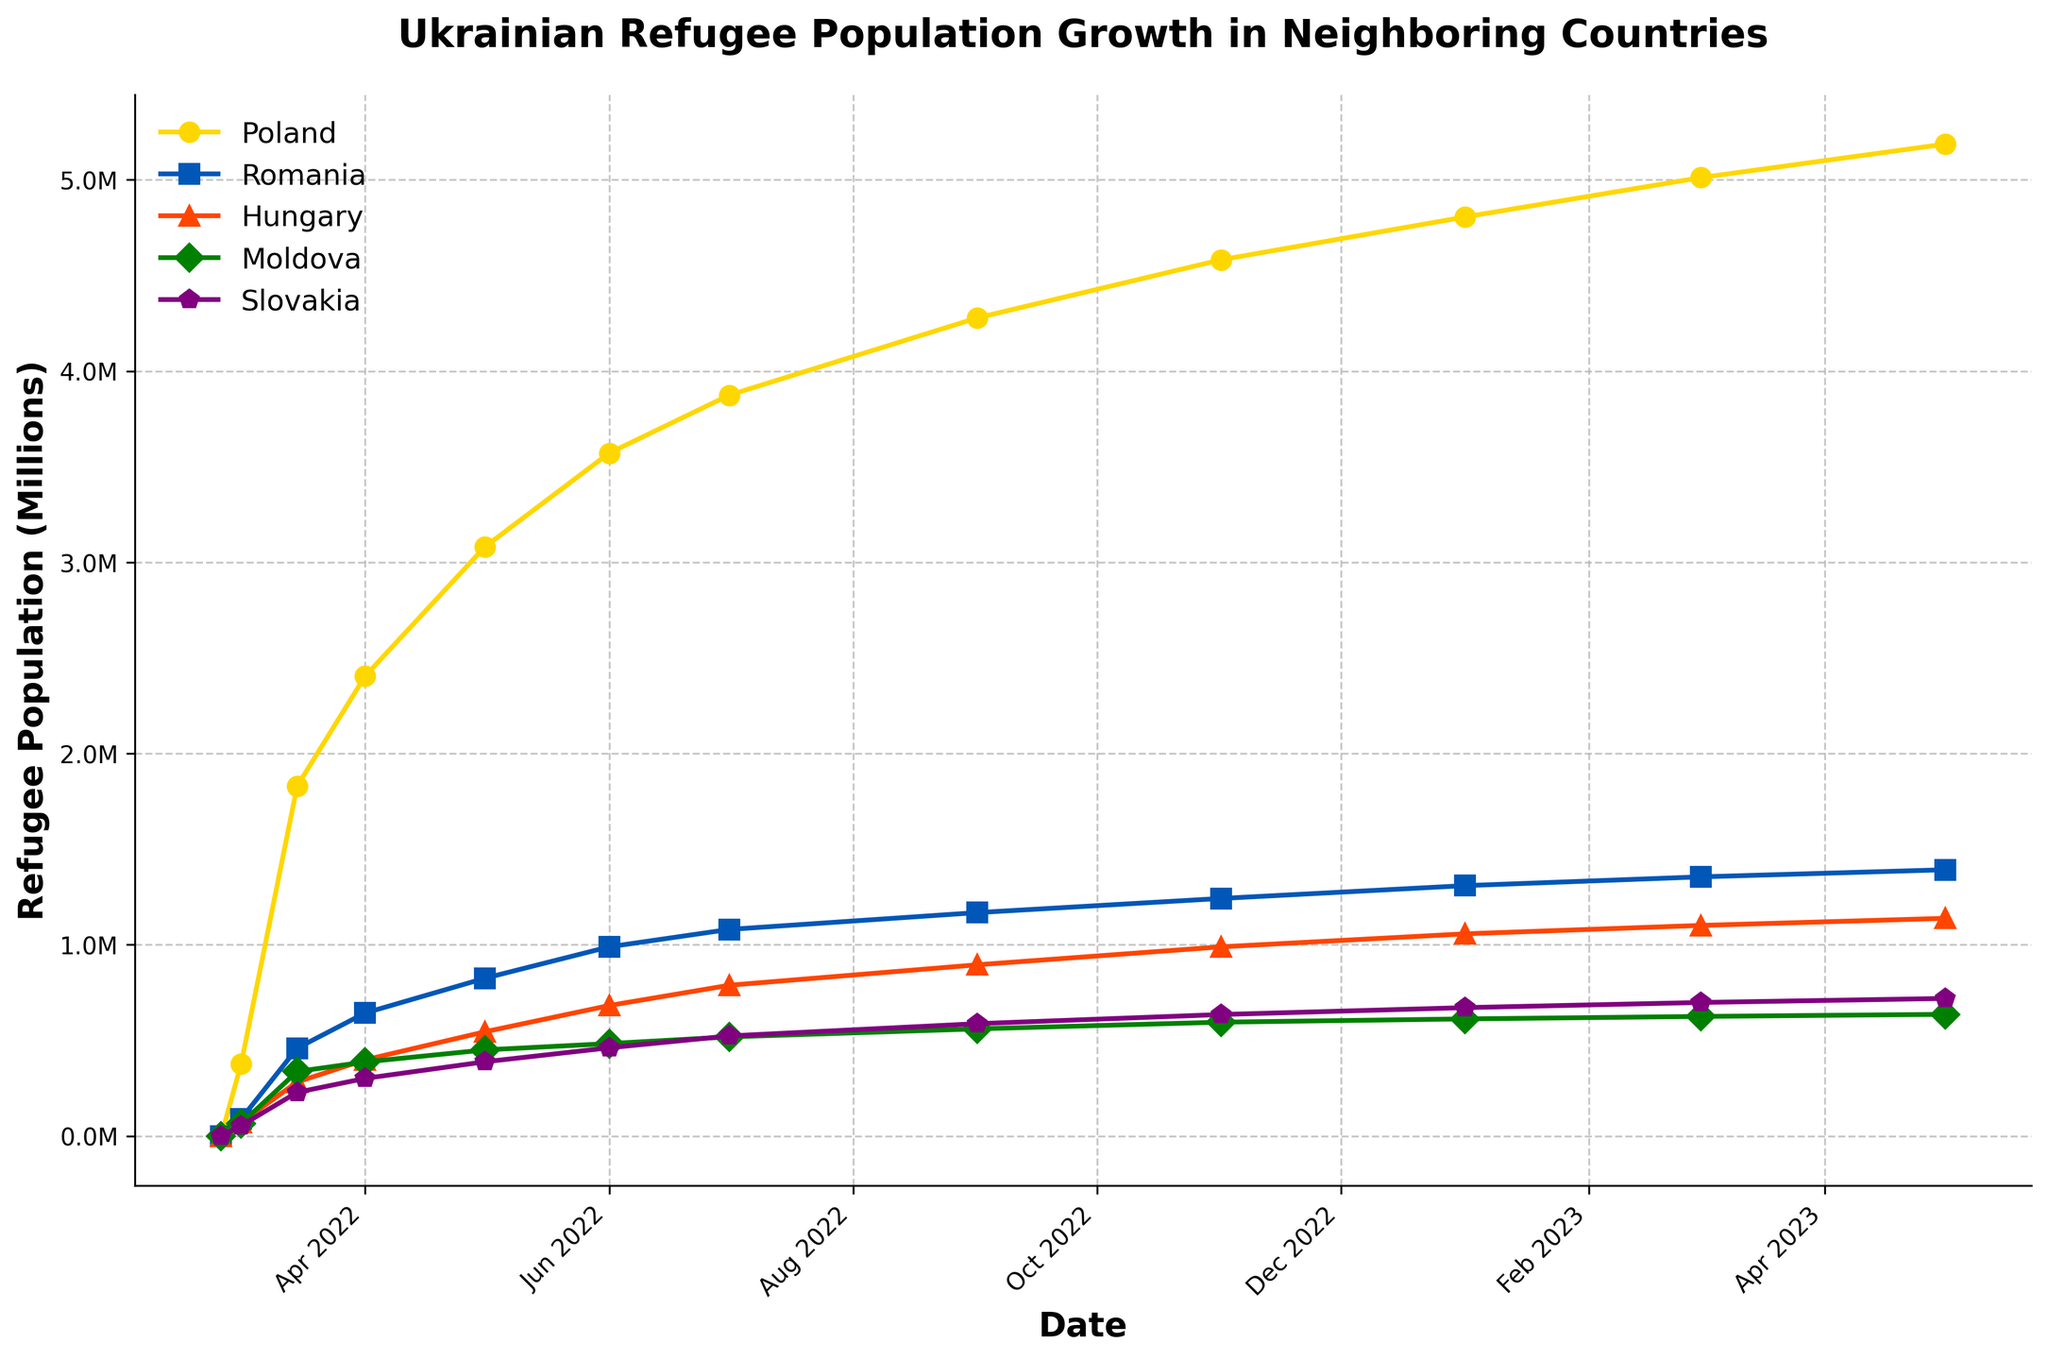Which country saw the greatest increase in the number of Ukrainian refugees between March 1, 2022, and May 1, 2023? To find the country with the greatest increase, subtract the number of refugees on March 1, 2022, from the number on May 1, 2023, for each country. The increases are: Poland: 5187000 - 377000 = 4800000; Romania: 1392000 - 89000 = 1303000; Hungary: 1138000 - 71000 = 1067000; Moldova: 636000 - 65000 = 571000; Slovakia: 719000 - 54000 = 665000. The greatest increase is in Poland.
Answer: Poland On which date did Poland surpass 3 million Ukrainian refugees? To find this, look for the first date when Poland's refugee population exceeds 3 million. From the plot, it is evident that Poland surpasses 3 million on May 1, 2022.
Answer: May 1, 2022 Which country has the least number of Ukrainian refugees as of May 1, 2023? Compare the numbers of refugees on May 1, 2023, for all countries. The numbers are: Poland: 5187000, Romania: 1392000, Hungary: 1138000, Moldova: 636000, Slovakia: 719000. The least number is in Moldova.
Answer: Moldova How many countries had over 1 million Ukrainian refugees by January 1, 2023? From the figure, evaluate the values for each country on January 1, 2023. Those over 1 million are: Poland (4806000), Romania (1309000), Hungary (1057000). That makes it three countries.
Answer: Three What was the total number of Ukrainian refugees in the five listed countries on March 15, 2022? Sum the numbers of refugees in all countries on March 15, 2022: Poland: 1830000, Romania: 459000, Hungary: 282000, Moldova: 337000, Slovakia: 228000. 1830000 + 459000 + 282000 + 337000 + 228000 = 3136000.
Answer: 3136000 How does the refugee population growth in Hungary compare to that in Slovakia between June 1, 2022, and March 1, 2023? Calculate the increase in refugees for both countries: Hungary: 1101000 - 682000 = 419000; Slovakia: 698000 - 461000 = 237000. Hungary's increase is greater than Slovakia's.
Answer: Hungary's increase is greater By what percentage did the number of Ukrainian refugees in Romania increase from March 1, 2022, to November 1, 2022? First, find the difference: 1242000 - 89000 = 1153000; then calculate the percentage increase: (1153000 / 89000) * 100 ≈ 1295.51%.
Answer: Approximately 1295.51% What is the trend in the number of Ukrainian refugees in Moldova from February 24, 2022, to May 1, 2023? The general trend for Moldova shows an initial rapid increase followed by a steadier growth. From 0 to about 483000 by June 1, 2022, then reaching 636000 by May 1, 2023.
Answer: Steady growth after rapid increase Which country shows a sustained increase without any decreases from February 24, 2022, to May 1, 2023? Assess each country's trend line for any decreases. Poland, Romania, Hungary, Moldova, and Slovakia all show sustained increases without any decreases.
Answer: All countries 